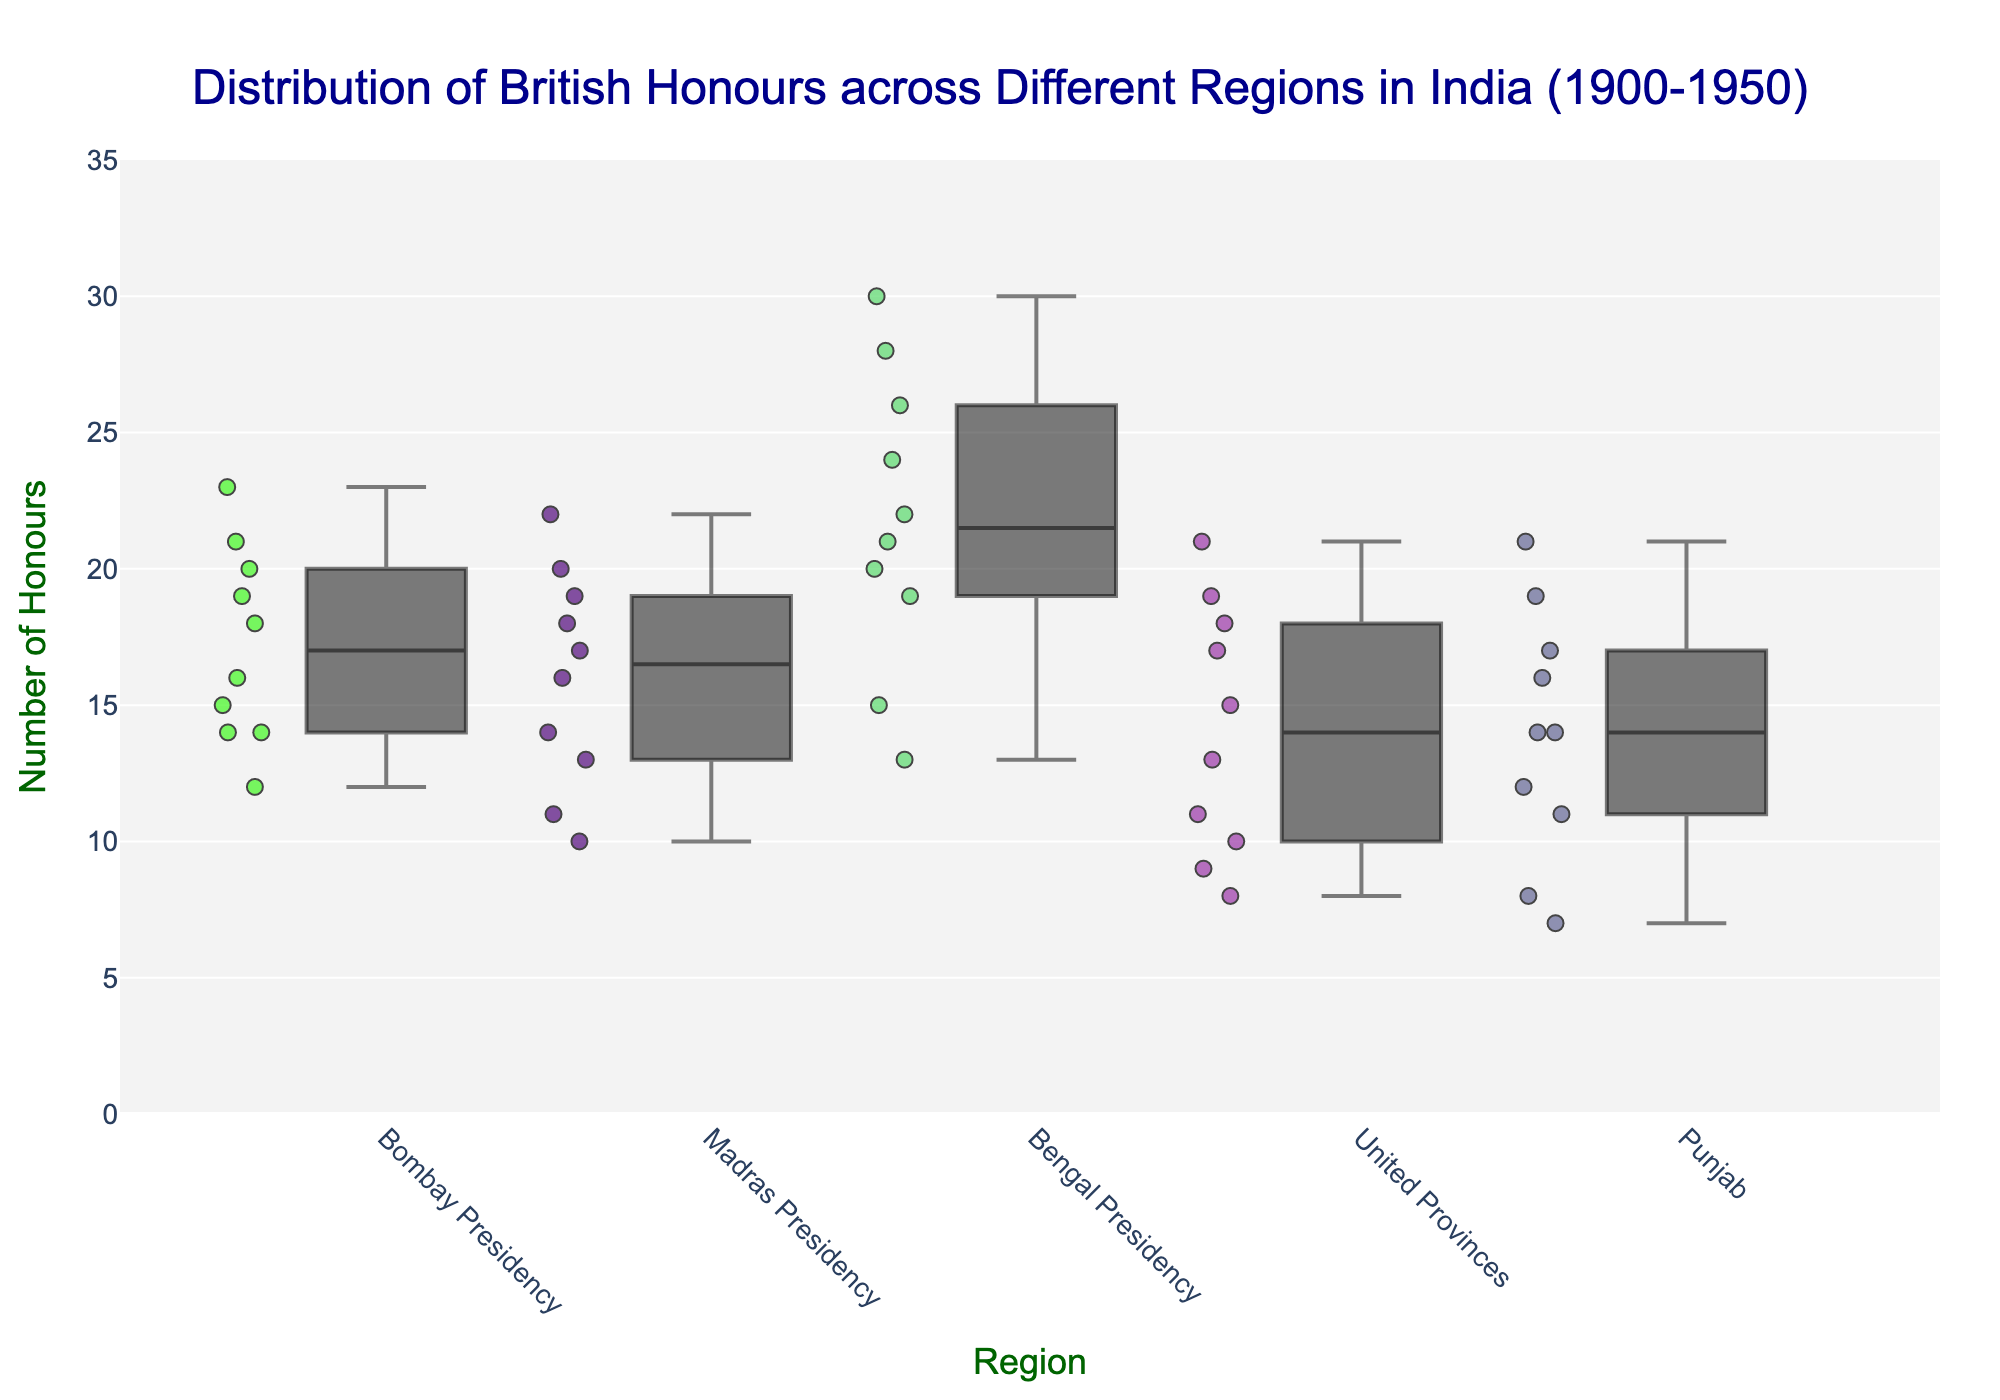What's the title of the figure? The title is located at the top center of the plot, which describes the overall content of the visualization.
Answer: Distribution of British Honours across Different Regions in India (1900-1950) What is the highest number of honours given in any year for the Bengal Presidency? By looking at the box plot for the Bengal Presidency, identify the highest data point, which represents the maximum number of honours.
Answer: 30 Which region received the least number of honours in any year, and what is that number? Examine the lowest data point across all box plots to find the region and the minimum number of honours.
Answer: Punjab, 7 Which region shows the greatest range of honours awarded? The range can be determined by the length of the box plot including the whiskers. Find the region where this range is the largest.
Answer: Bengal Presidency What’s the median number of honours awarded in the Madras Presidency? On the box plot for the Madras Presidency, find the line inside the box which represents the median.
Answer: 17 Between the Bombay Presidency and United Provinces, which region had a higher median number of honours? Compare the median lines within the box plots for both Bombay Presidency and United Provinces to see which is higher.
Answer: Bombay Presidency How many regions have outliers in their honours distribution? Outliers are shown as individual points outside the whiskers in a box plot. Count the number of regions that display such points.
Answer: 0 Which region saw the most significant increase in the number of honours from their lowest to highest recorded value? This can be determined by looking at the difference between the minimum and maximum values for each region's box plot. The region with the largest difference indicates the most significant increase.
Answer: Bengal Presidency What is the interquartile range (IQR) of the honours for the Punjab region? The IQR in a box plot is represented by the length of the box itself, from the lower quartile (Q1) to the upper quartile (Q3). Measure this range for the Punjab region.
Answer: 7 Which regions' distributions have more overlap with each other based on the box plots? Overlapping distributions can be seen where the boxes and whiskers of different regions cover similar ranges. Identify these regions by observing their plot areas.
Answer: Bombay Presidency and Madras Presidency 